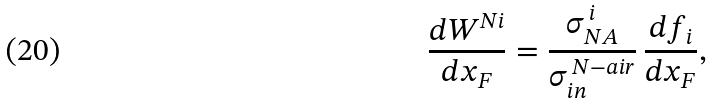<formula> <loc_0><loc_0><loc_500><loc_500>\frac { d W ^ { N i } } { d x _ { F } } = \frac { \sigma _ { N A } ^ { \, i } } { \sigma _ { i n } ^ { \, N - a i r } } \, \frac { d f _ { i } } { d x _ { F } } ,</formula> 